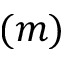<formula> <loc_0><loc_0><loc_500><loc_500>( m )</formula> 